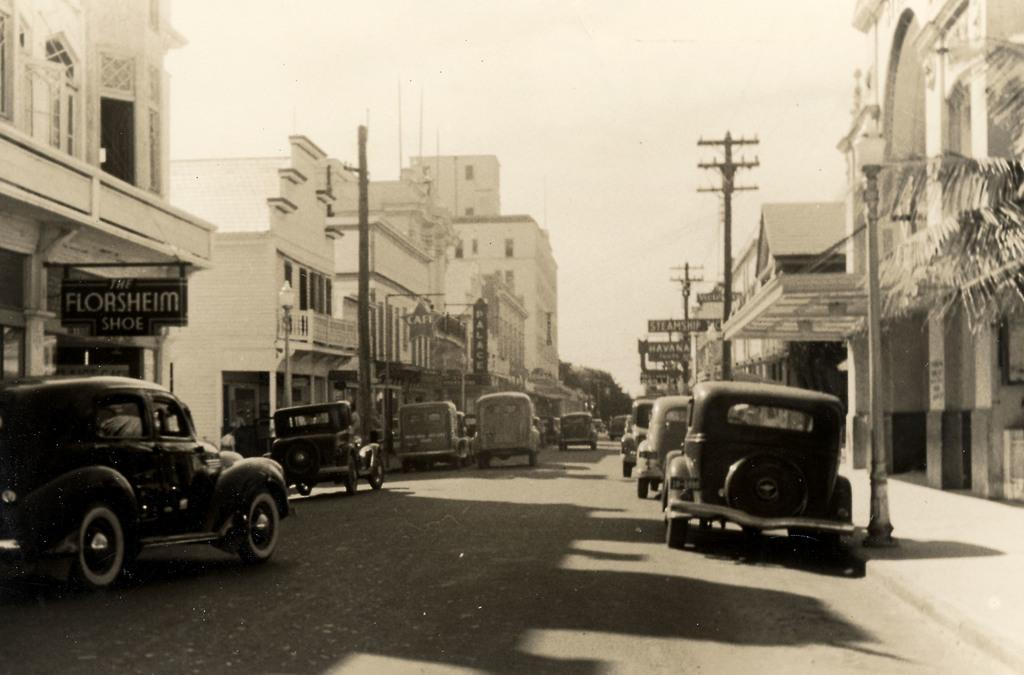What type of vehicles can be seen in the image? There are cars in the image. What structures are present in the image? There are buildings in the image. What type of natural elements are visible in the image? There are trees in the image. What man-made structures are present for electrical purposes? There are electric poles in the image. What type of informational signs are present in the image? There are signboards in the image. Can any text be read in the image? Yes, there is text visible in the image. What type of pathway is present in the image? There is a road in the image. What part of the natural environment is visible in the image? The sky is visible in the image. What type of tent is set up near the electric poles in the image? There is no tent present in the image; it features cars, buildings, trees, electric poles, signboards, text, a road, and the sky. Who is the expert on the degree of the road's incline in the image? There is no mention of an expert or a degree of incline in the image. 